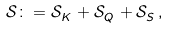Convert formula to latex. <formula><loc_0><loc_0><loc_500><loc_500>\mathcal { S } \colon = \mathcal { S } ^ { \ } _ { K } + \mathcal { S } ^ { \ } _ { Q } + \mathcal { S } ^ { \ } _ { S } ,</formula> 